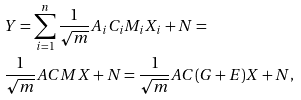Convert formula to latex. <formula><loc_0><loc_0><loc_500><loc_500>& Y = \sum _ { i = 1 } ^ { n } \frac { 1 } { \sqrt { m } } A _ { i } C _ { i } M _ { i } X _ { i } + N = \\ & \frac { 1 } { \sqrt { m } } A C M X + N = \frac { 1 } { \sqrt { m } } A C ( G + E ) X + N ,</formula> 